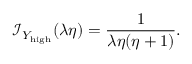Convert formula to latex. <formula><loc_0><loc_0><loc_500><loc_500>\mathcal { I } _ { { Y _ { h i g h } } } ( \lambda \eta ) = \frac { 1 } { \lambda \eta ( \eta + 1 ) } .</formula> 